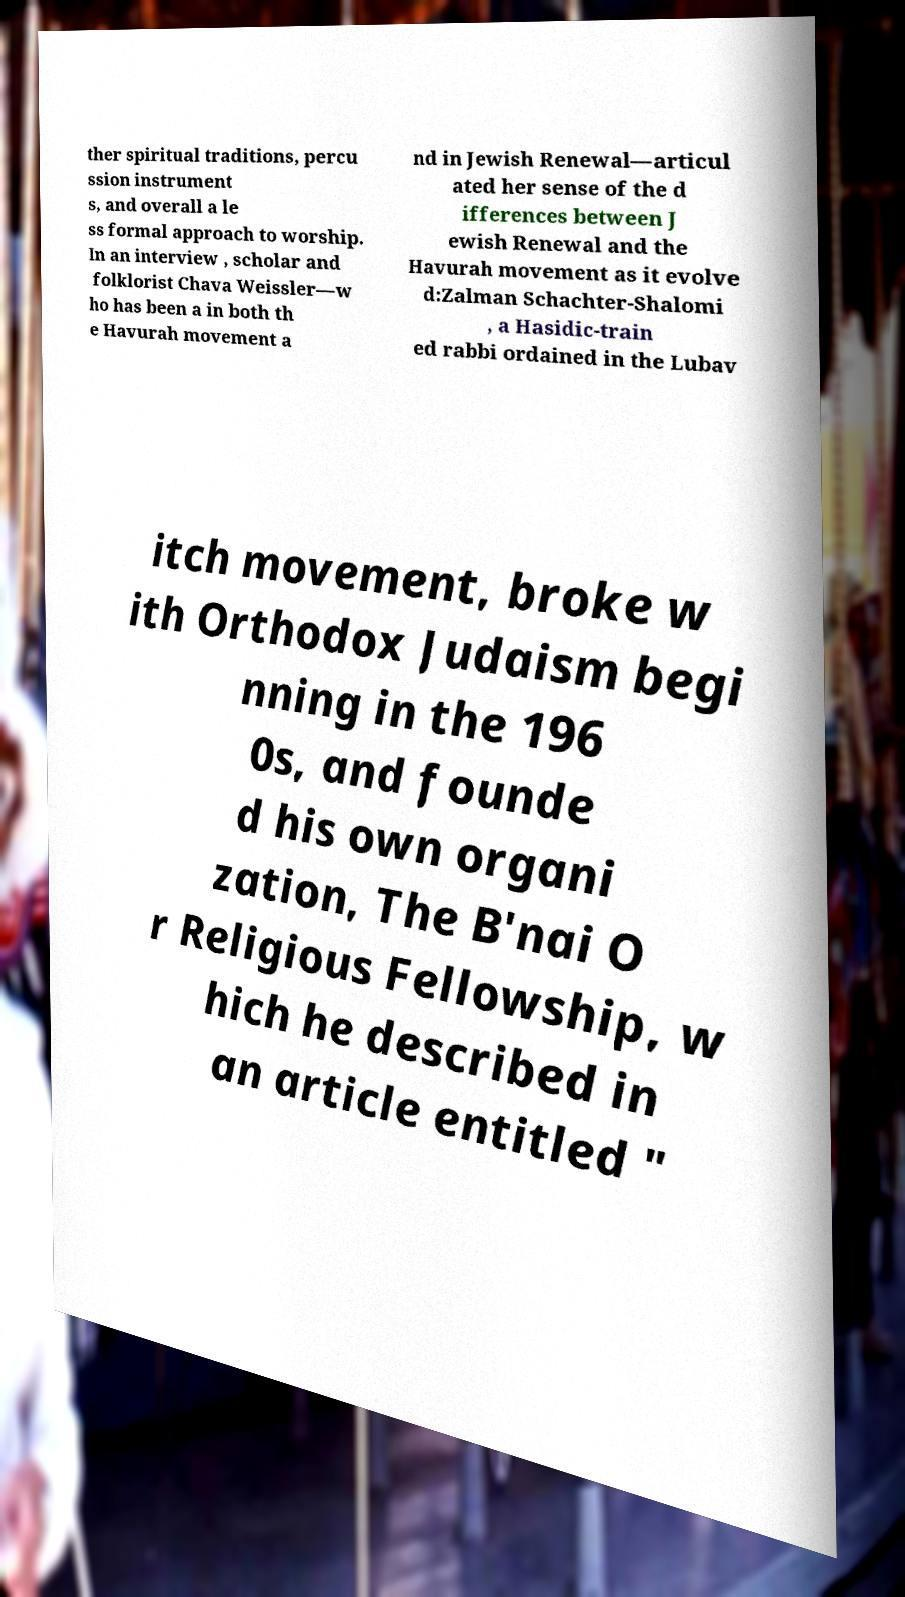I need the written content from this picture converted into text. Can you do that? ther spiritual traditions, percu ssion instrument s, and overall a le ss formal approach to worship. In an interview , scholar and folklorist Chava Weissler—w ho has been a in both th e Havurah movement a nd in Jewish Renewal—articul ated her sense of the d ifferences between J ewish Renewal and the Havurah movement as it evolve d:Zalman Schachter-Shalomi , a Hasidic-train ed rabbi ordained in the Lubav itch movement, broke w ith Orthodox Judaism begi nning in the 196 0s, and founde d his own organi zation, The B'nai O r Religious Fellowship, w hich he described in an article entitled " 